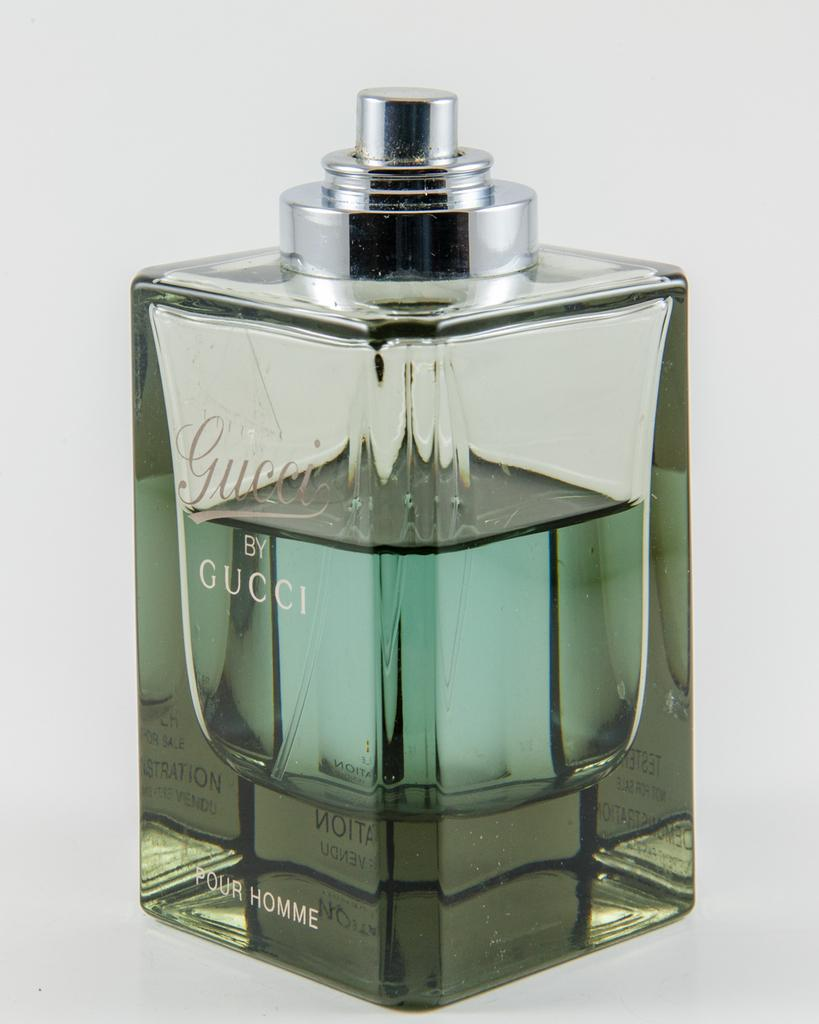<image>
Create a compact narrative representing the image presented. A Four Home fragrance bottle features the label Gucci by Gucci. 